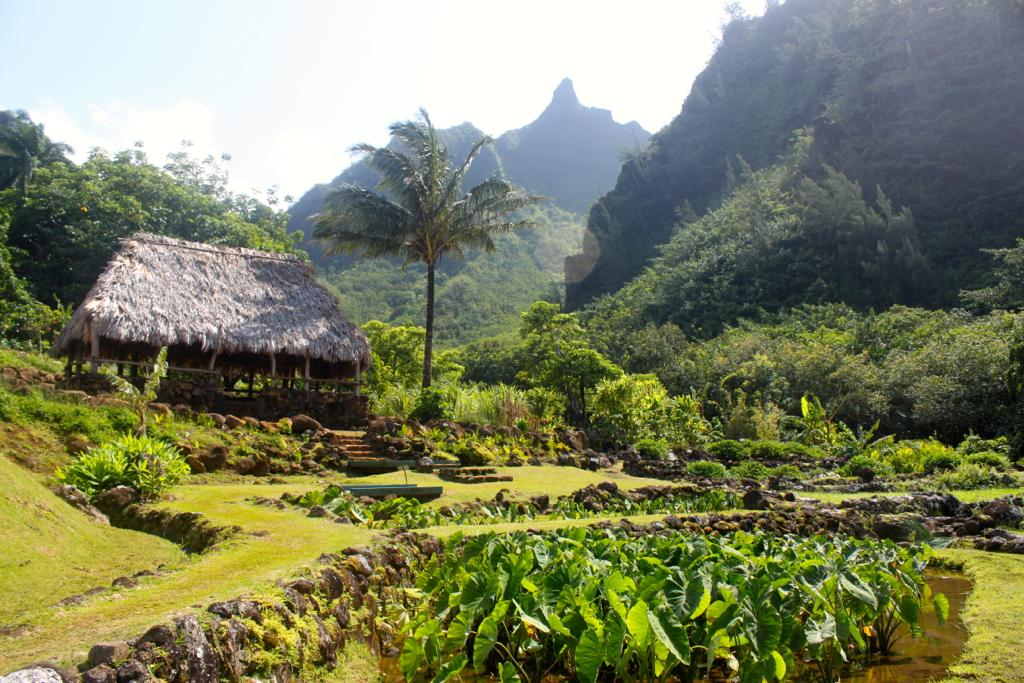What type of animal is present in the image? There is a hurt in the image. What type of natural environment is depicted in the image? There are trees, plants, and rocks in the image. What type of crow is perched on the hurt's fang in the image? There is no crow or fang present in the image; it features a hurt in a natural environment with trees, plants, and rocks. 